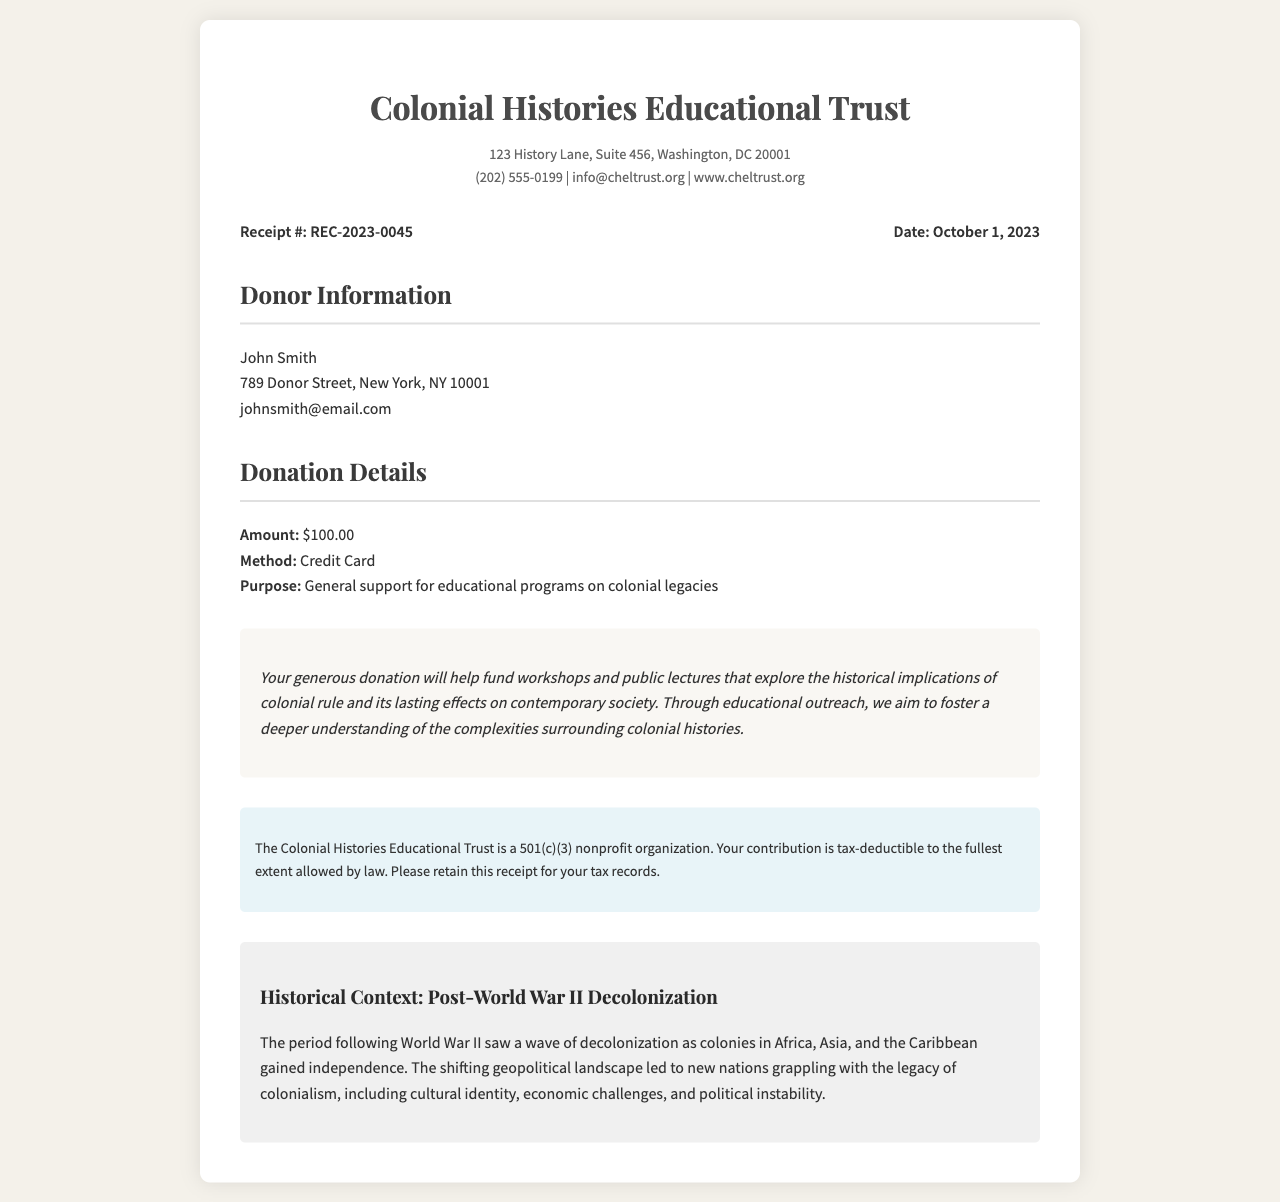What is the organization's name? The organization's name is stated clearly at the top of the receipt.
Answer: Colonial Histories Educational Trust What is the receipt number? The receipt number is provided in the receipt details section.
Answer: REC-2023-0045 When was the donation made? The date of the receipt shows when the donation was processed.
Answer: October 1, 2023 What is the donation amount? The amount of the donation is specified in the donation details section.
Answer: $100.00 What is the purpose of the donation? The purpose of the donation is indicated directly in the donation details.
Answer: General support for educational programs on colonial legacies Who is the donor? The donor's name is listed in the donor information section.
Answer: John Smith What type of organization is the Colonial Histories Educational Trust? This indicates the status of the organization found in the tax information section.
Answer: 501(c)(3) nonprofit organization What will the donation help fund? The impact statement outlines how the donation will be utilized.
Answer: Workshops and public lectures What is the contact email for the organization? The contact email is included in the organization details at the top.
Answer: info@cheltrust.org What historical context is provided in the document? The historical context discusses a specific period mentioned at the end of the receipt.
Answer: Post-World War II Decolonization 